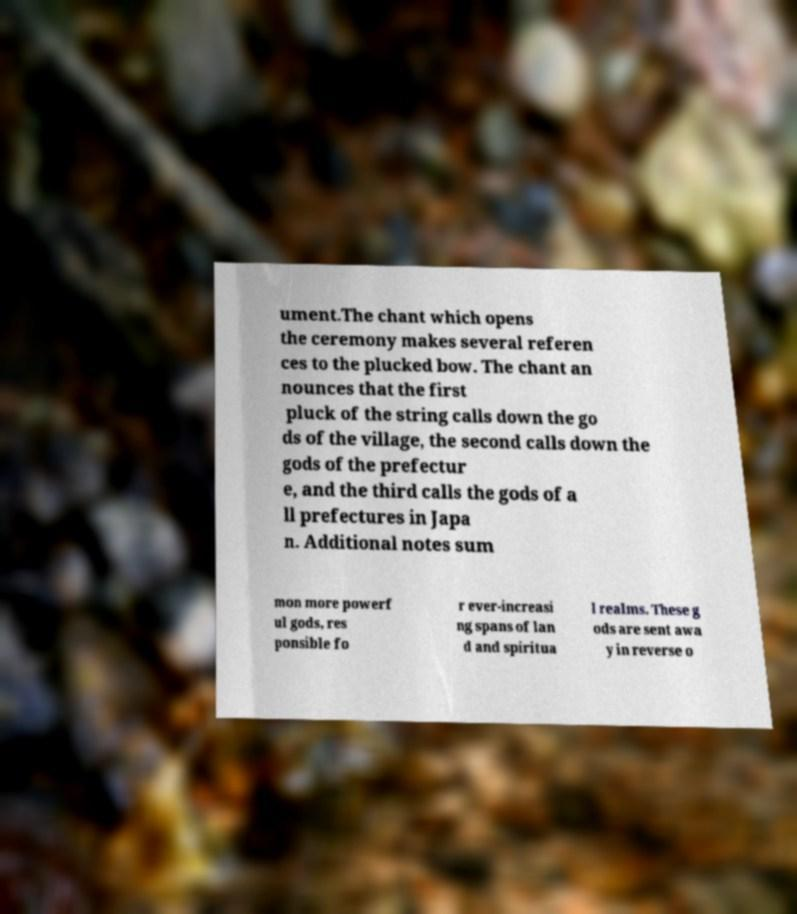I need the written content from this picture converted into text. Can you do that? ument.The chant which opens the ceremony makes several referen ces to the plucked bow. The chant an nounces that the first pluck of the string calls down the go ds of the village, the second calls down the gods of the prefectur e, and the third calls the gods of a ll prefectures in Japa n. Additional notes sum mon more powerf ul gods, res ponsible fo r ever-increasi ng spans of lan d and spiritua l realms. These g ods are sent awa y in reverse o 